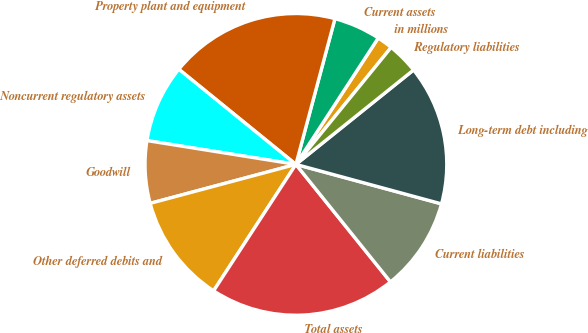Convert chart. <chart><loc_0><loc_0><loc_500><loc_500><pie_chart><fcel>in millions<fcel>Current assets<fcel>Property plant and equipment<fcel>Noncurrent regulatory assets<fcel>Goodwill<fcel>Other deferred debits and<fcel>Total assets<fcel>Current liabilities<fcel>Long-term debt including<fcel>Regulatory liabilities<nl><fcel>1.69%<fcel>5.02%<fcel>18.31%<fcel>8.34%<fcel>6.68%<fcel>11.66%<fcel>19.97%<fcel>10.0%<fcel>14.98%<fcel>3.36%<nl></chart> 